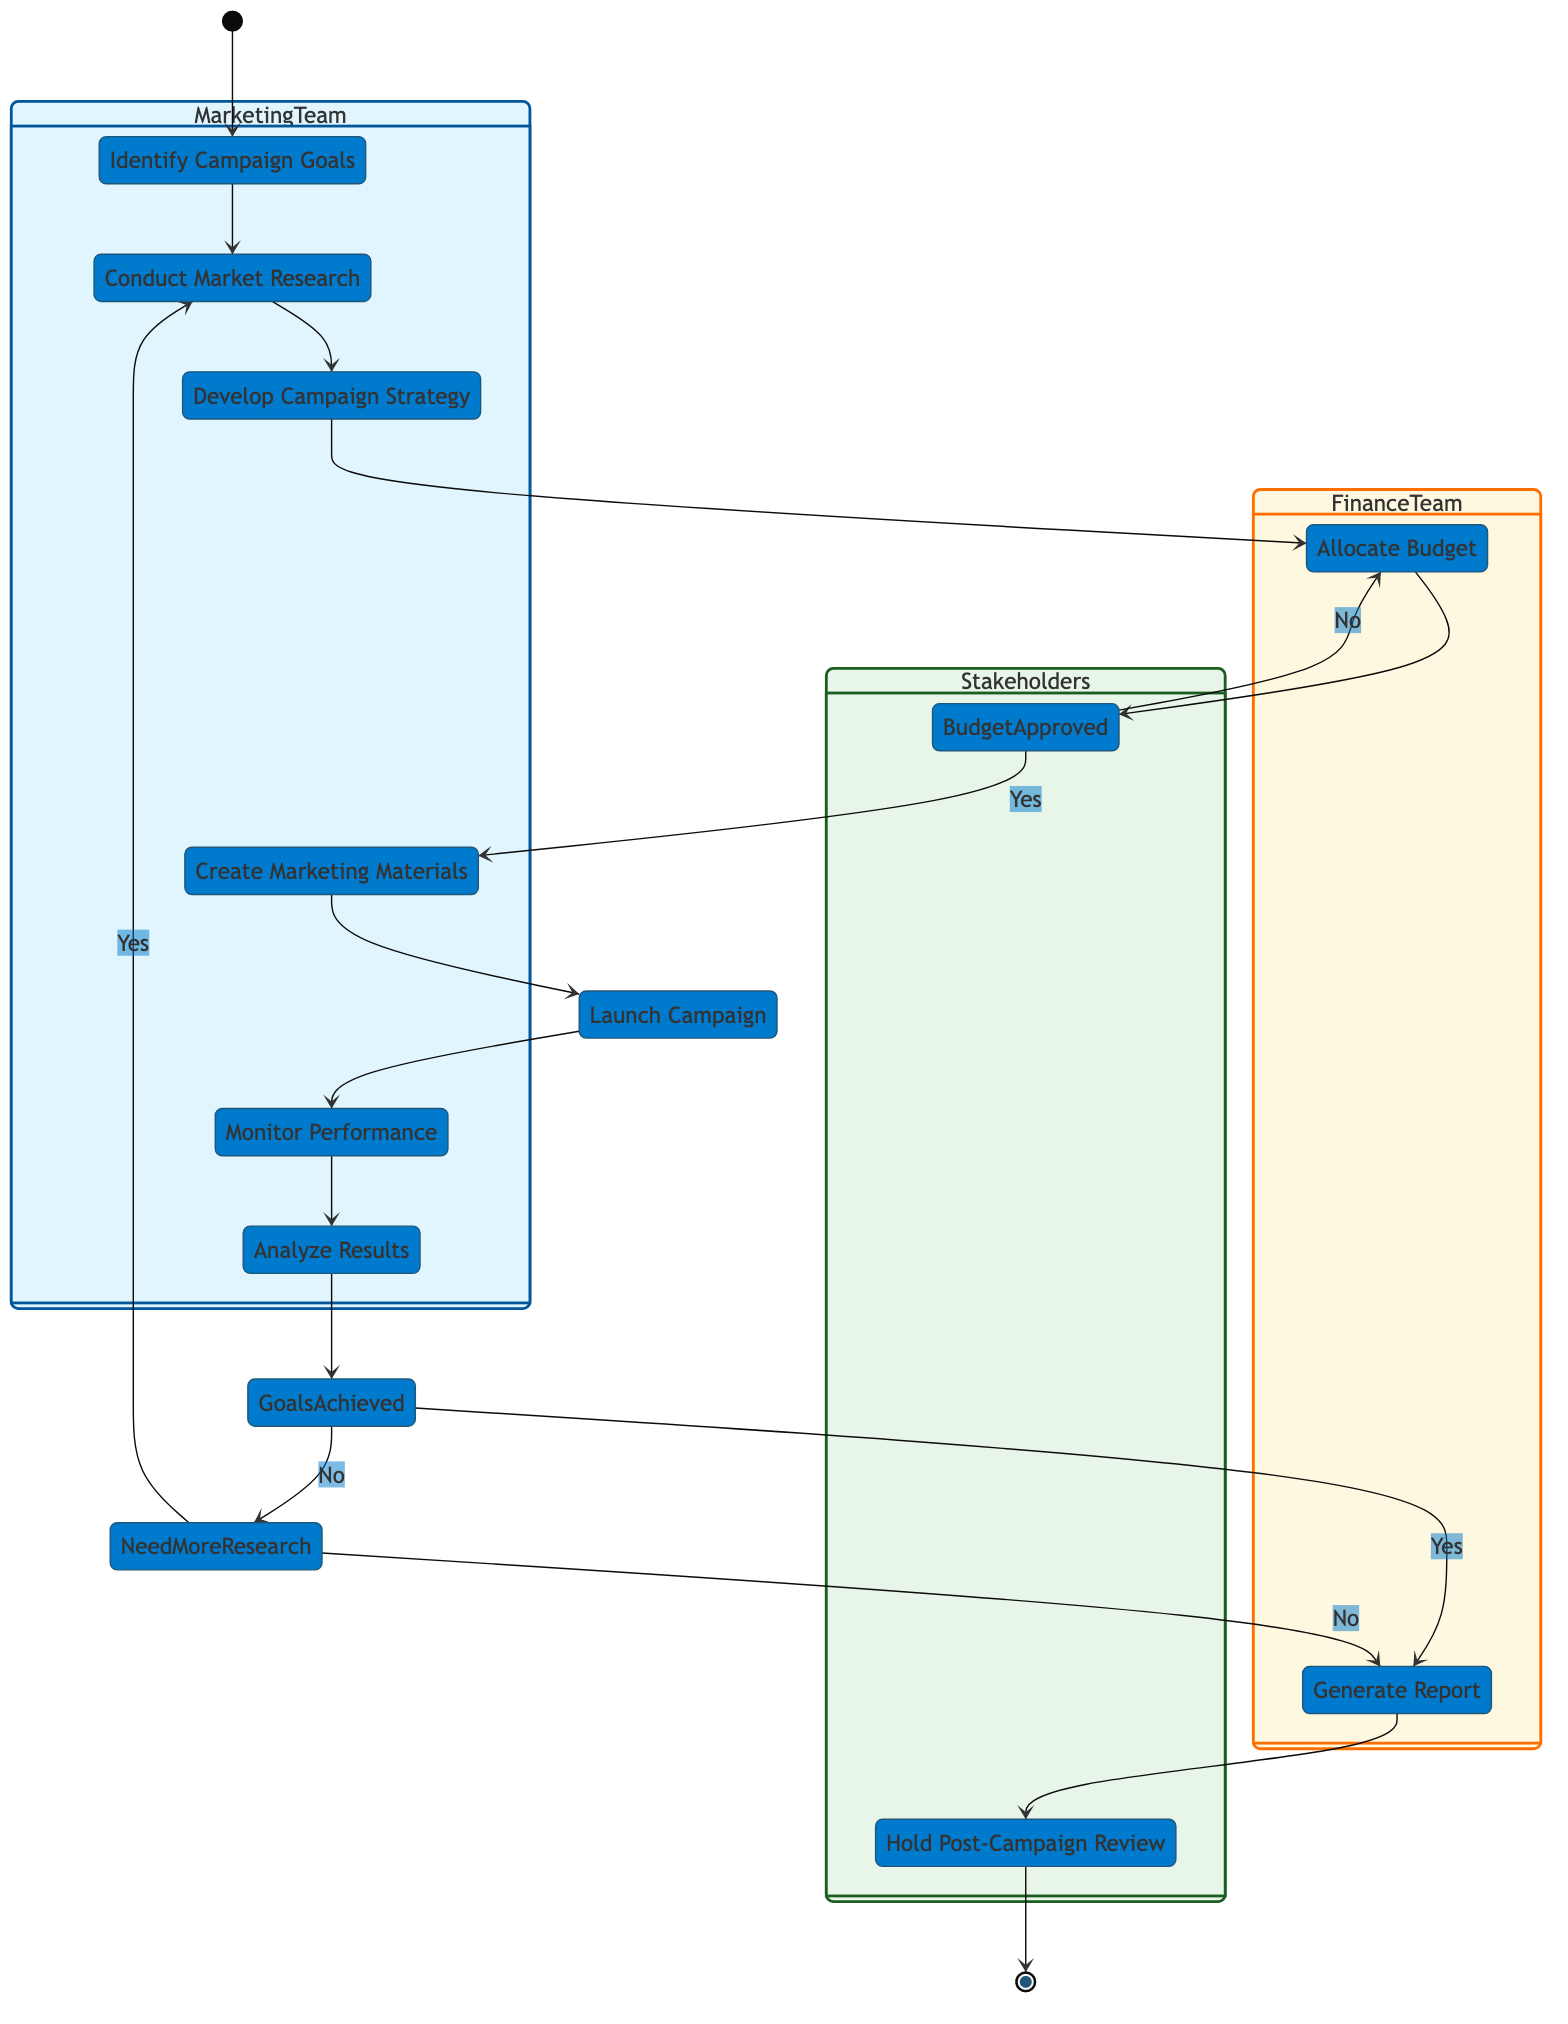What is the first action in the diagram? The diagram starts with the initial node leading to the action "Identify Campaign Goals", signifying it's the first step taken in the campaign execution process.
Answer: Identify Campaign Goals How many actions are there in total? Counting all the action nodes listed in the diagram, there are 10 distinct actions that outline the steps of the marketing campaign execution.
Answer: 10 Which team is responsible for monitoring performance? The swimlane for the Marketing Team includes the action "Monitor Performance", identifying it as their responsibility in the campaign execution process.
Answer: Marketing Team What happens if the budget is not approved? In the diagram, if "Is Campaign Budget Approved?" is answered as "No", the flow leads back to "Allocate Budget", indicating the process will revisit budget allocation.
Answer: Allocate Budget What are the two outcomes of analyzing results? After the "Analyze Results" action, the decision point evaluates if "Are Campaign Goals Achieved?" with outcomes leading either to "Generate Report" or "Need More Research".
Answer: Generate Report, Need More Research What is the last action before the campaign review? Before the "Hold Post-Campaign Review" action, the last action is "Generate Report", which compiles the findings and insights from the marketing campaign.
Answer: Generate Report If the additional market research is needed, which action will be revisited? The "Is Additional Market Research Needed?" decision leads to the action "Conduct Market Research" being revisited if the answer is "Yes".
Answer: Conduct Market Research Which team has the responsibility to generate the report? The responsibility to "Generate Report" lies within the Finance Team's swimlane, indicating their role in compiling the findings of the campaign.
Answer: Finance Team How many decision points are present in the diagram? There are 3 decision points in the diagram evaluating budget approval, achievement of campaign goals, and the need for additional market research.
Answer: 3 